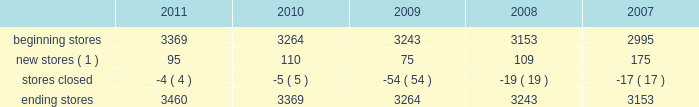The table sets forth information concerning increases in the total number of our aap stores during the past five years : beginning stores new stores ( 1 ) stores closed ending stores ( 1 ) does not include stores that opened as relocations of previously existing stores within the same general market area or substantial renovations of stores .
Our store-based information systems , which are designed to improve the efficiency of our operations and enhance customer service , are comprised of a proprietary pos system and electronic parts catalog , or epc , system .
Information maintained by our pos system is used to formulate pricing , marketing and merchandising strategies and to replenish inventory accurately and rapidly .
Our pos system is fully integrated with our epc system and enables our store team members to assist our customers in their parts selection and ordering based on the year , make , model and engine type of their vehicles .
Our centrally-based epc data management system enables us to reduce the time needed to ( i ) exchange data with our vendors and ( ii ) catalog and deliver updated , accurate parts information .
Our epc system also contains enhanced search engines and user-friendly navigation tools that enhance our team members' ability to look up any needed parts as well as additional products the customer needs to complete an automotive repair project .
If a hard-to-find part or accessory is not available at one of our stores , the epc system can determine whether the part is carried and in-stock through our hub or pdq ae networks or can be ordered directly from one of our vendors .
Available parts and accessories are then ordered electronically from another store , hub , pdq ae or directly from the vendor with immediate confirmation of price , availability and estimated delivery time .
We also support our store operations with additional proprietary systems and customer driven labor scheduling capabilities .
Our store-level inventory management system provides real-time inventory tracking at the store level .
With the store-level system , store team members can check the quantity of on-hand inventory for any sku , adjust stock levels for select items for store specific events , automatically process returns and defective merchandise , designate skus for cycle counts and track merchandise transfers .
Our stores use radio frequency hand-held devices to help ensure the accuracy of our inventory .
Our standard operating procedure , or sop , system is a web-based , electronic data management system that provides our team members with instant access to any of our standard operating procedures through a comprehensive on-line search function .
All of these systems are tightly integrated and provide real-time , comprehensive information to store personnel , resulting in improved customer service levels , team member productivity and in-stock availability .
Purchasing for virtually all of the merchandise for our stores is handled by our merchandise teams located in three primary locations : 2022 store support center in roanoke , virginia ; 2022 regional office in minneapolis , minnesota ; and 2022 global sourcing office in taipei , taiwan .
Our roanoke team is primarily responsible for the parts categories and our minnesota team is primarily responsible for accessories , oil and chemicals .
Our global sourcing team works closely with both teams .
In fiscal 2011 , we purchased merchandise from approximately 500 vendors , with no single vendor accounting for more than 9% ( 9 % ) of purchases .
Our purchasing strategy involves negotiating agreements with most of our vendors to purchase merchandise over a specified period of time along with other terms , including pricing , payment terms and volume .
The merchandising team has developed strong vendor relationships in the industry and , in a collaborative effort with our vendor partners , utilizes a category management process where we manage the mix of our product offerings to meet customer demand .
We believe this process , which develops a customer-focused business plan for each merchandise category , and our global sourcing operation are critical to improving comparable store sales , gross margin and inventory productivity. .
The following table sets forth information concerning increases in the total number of our aap stores during the past five years : beginning stores new stores ( 1 ) stores closed ending stores ( 1 ) does not include stores that opened as relocations of previously existing stores within the same general market area or substantial renovations of stores .
Our store-based information systems , which are designed to improve the efficiency of our operations and enhance customer service , are comprised of a proprietary pos system and electronic parts catalog , or epc , system .
Information maintained by our pos system is used to formulate pricing , marketing and merchandising strategies and to replenish inventory accurately and rapidly .
Our pos system is fully integrated with our epc system and enables our store team members to assist our customers in their parts selection and ordering based on the year , make , model and engine type of their vehicles .
Our centrally-based epc data management system enables us to reduce the time needed to ( i ) exchange data with our vendors and ( ii ) catalog and deliver updated , accurate parts information .
Our epc system also contains enhanced search engines and user-friendly navigation tools that enhance our team members' ability to look up any needed parts as well as additional products the customer needs to complete an automotive repair project .
If a hard-to-find part or accessory is not available at one of our stores , the epc system can determine whether the part is carried and in-stock through our hub or pdq ae networks or can be ordered directly from one of our vendors .
Available parts and accessories are then ordered electronically from another store , hub , pdq ae or directly from the vendor with immediate confirmation of price , availability and estimated delivery time .
We also support our store operations with additional proprietary systems and customer driven labor scheduling capabilities .
Our store-level inventory management system provides real-time inventory tracking at the store level .
With the store-level system , store team members can check the quantity of on-hand inventory for any sku , adjust stock levels for select items for store specific events , automatically process returns and defective merchandise , designate skus for cycle counts and track merchandise transfers .
Our stores use radio frequency hand-held devices to help ensure the accuracy of our inventory .
Our standard operating procedure , or sop , system is a web-based , electronic data management system that provides our team members with instant access to any of our standard operating procedures through a comprehensive on-line search function .
All of these systems are tightly integrated and provide real-time , comprehensive information to store personnel , resulting in improved customer service levels , team member productivity and in-stock availability .
Purchasing for virtually all of the merchandise for our stores is handled by our merchandise teams located in three primary locations : 2022 store support center in roanoke , virginia ; 2022 regional office in minneapolis , minnesota ; and 2022 global sourcing office in taipei , taiwan .
Our roanoke team is primarily responsible for the parts categories and our minnesota team is primarily responsible for accessories , oil and chemicals .
Our global sourcing team works closely with both teams .
In fiscal 2011 , we purchased merchandise from approximately 500 vendors , with no single vendor accounting for more than 9% ( 9 % ) of purchases .
Our purchasing strategy involves negotiating agreements with most of our vendors to purchase merchandise over a specified period of time along with other terms , including pricing , payment terms and volume .
The merchandising team has developed strong vendor relationships in the industry and , in a collaborative effort with our vendor partners , utilizes a category management process where we manage the mix of our product offerings to meet customer demand .
We believe this process , which develops a customer-focused business plan for each merchandise category , and our global sourcing operation are critical to improving comparable store sales , gross margin and inventory productivity. .
What was the percentage increase in stores from 2007 to 2011? 
Rationale: one can figure out the increase in percentage of stores by subtracting the end store total from 2011 by the store total of 2007 . then taking that answer and dividing it by the store total for 2007 .
Computations: ((3460 - 3153) / 3153)
Answer: 0.09737. 